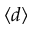Convert formula to latex. <formula><loc_0><loc_0><loc_500><loc_500>\langle d \rangle</formula> 